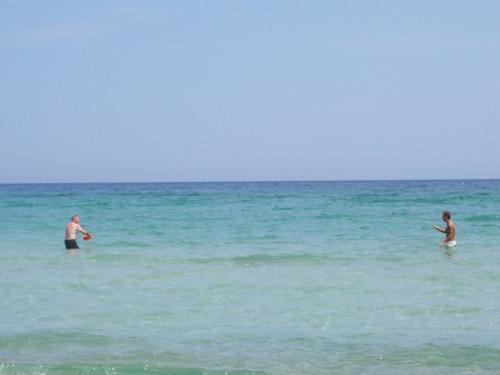How many men are pictured?
Give a very brief answer. 2. How many people are in the water?
Give a very brief answer. 2. How many people are in this photo?
Give a very brief answer. 2. How many cups are in this photo?
Give a very brief answer. 0. 